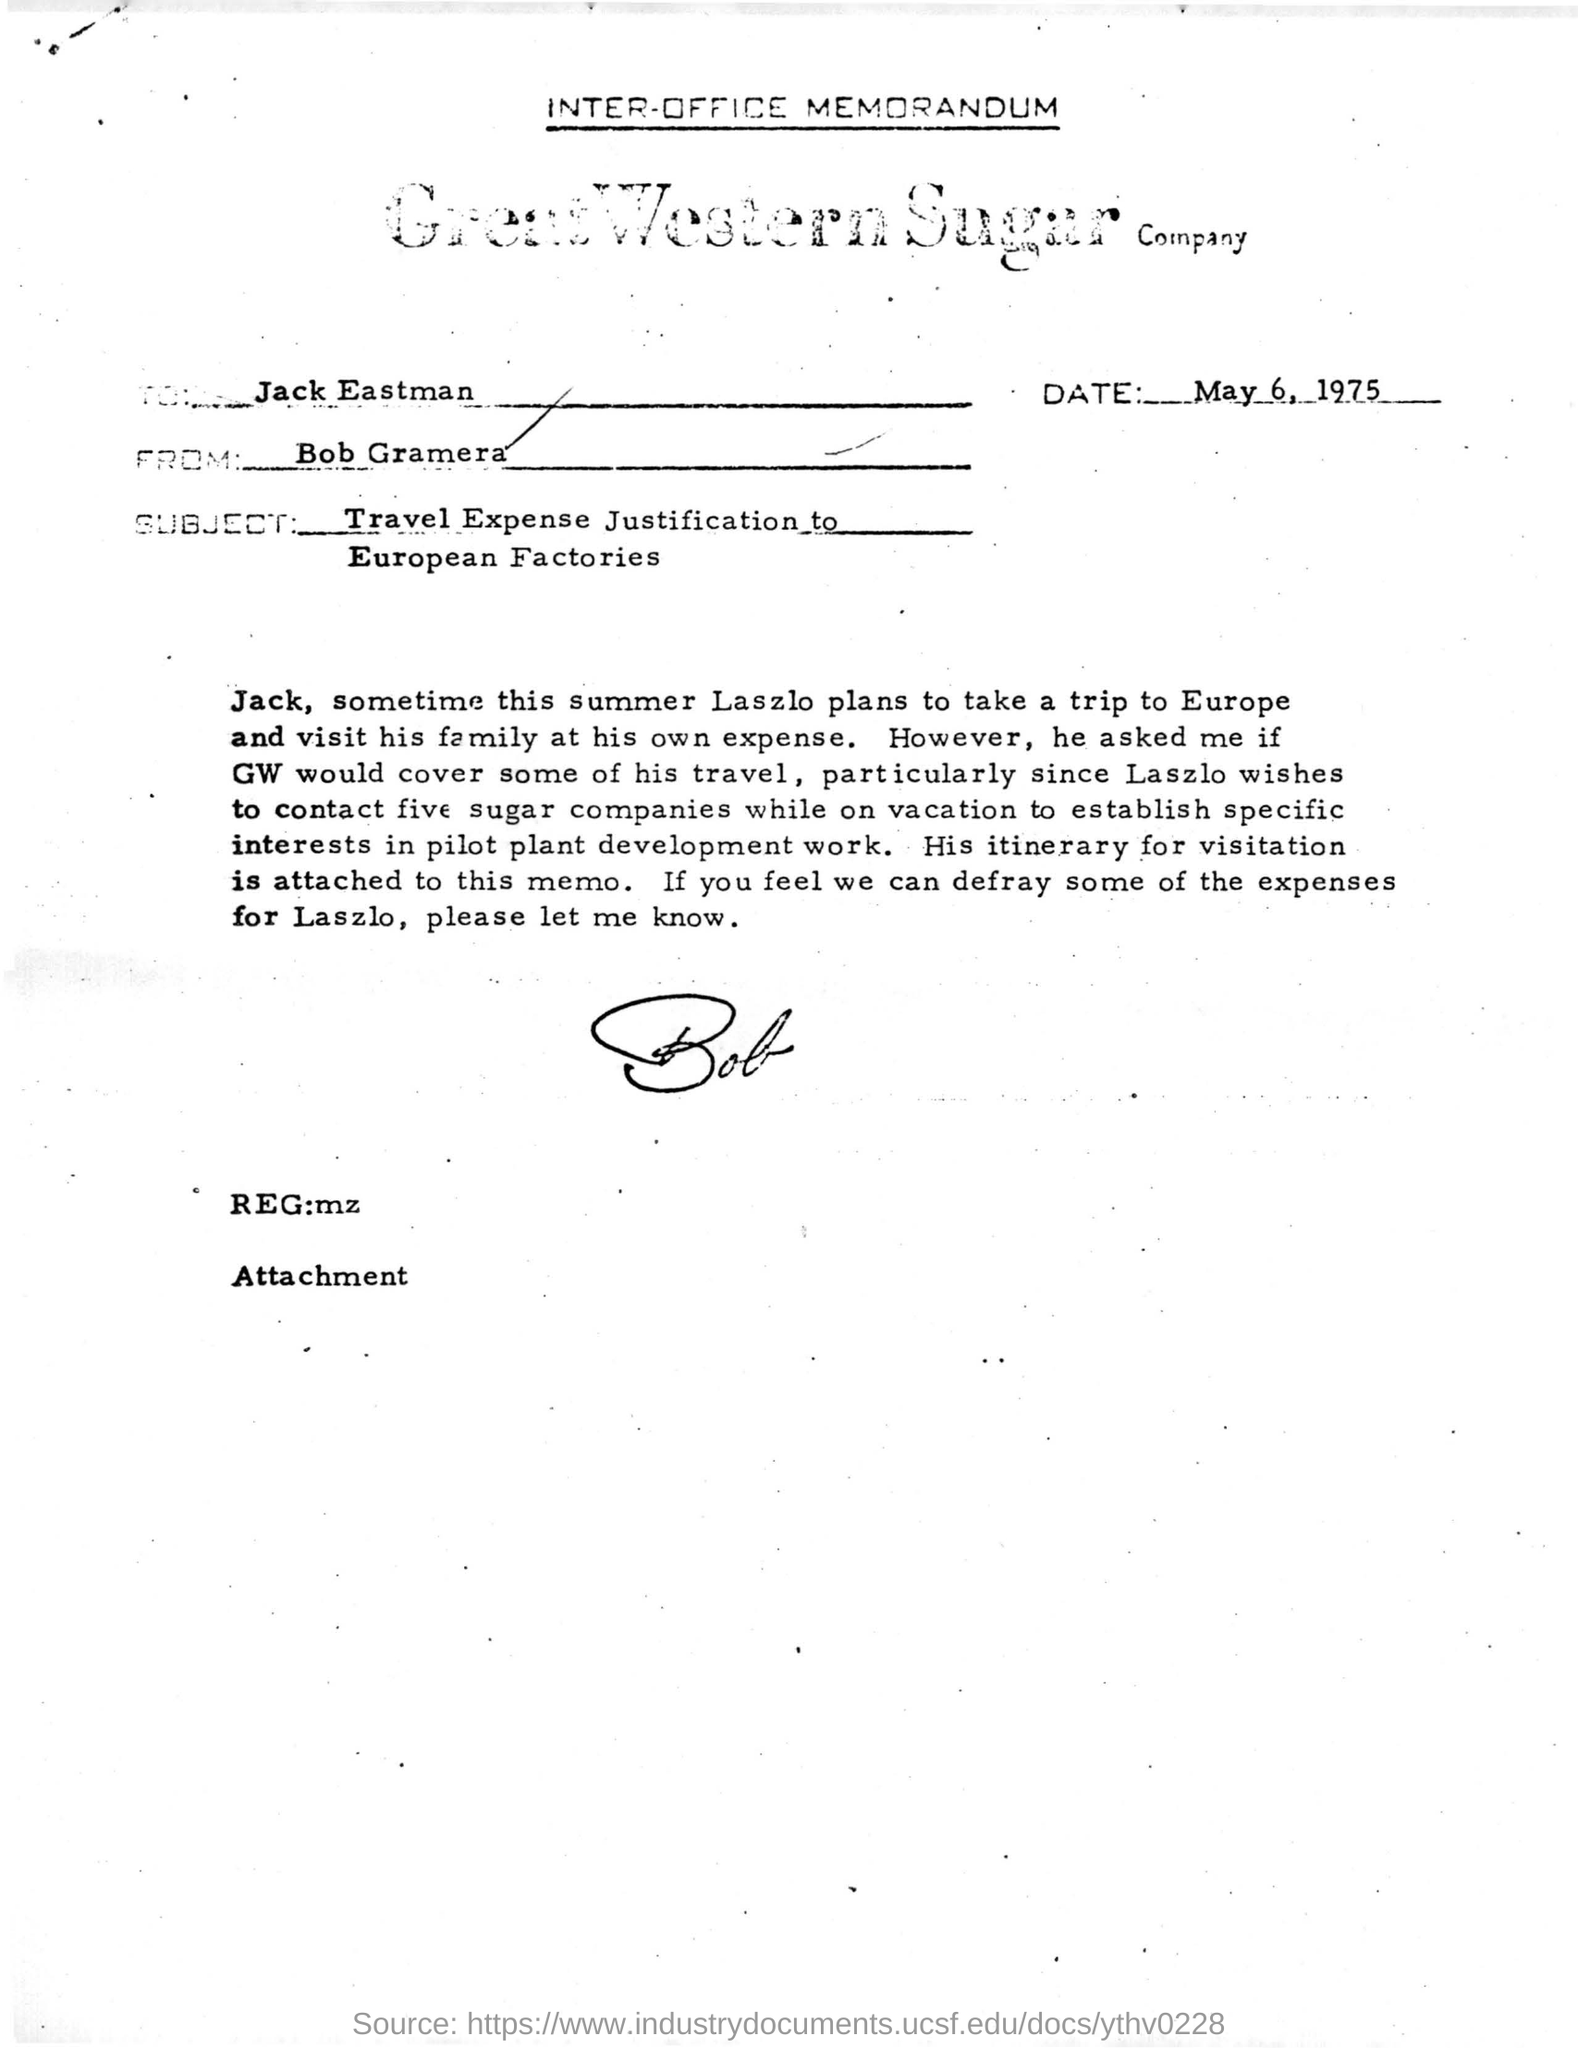What is the date of this document?
Your answer should be compact. May 6, 1975. What is the company's name in this page?
Your response must be concise. Great Western Sugar Company. To whom this letter is addressed?
Offer a very short reply. Jack Eastman. Who is the sender of this letter?
Keep it short and to the point. Bob Gramera. What is the subject of this letter?
Provide a short and direct response. Travel Expense Justification to European Factories. 